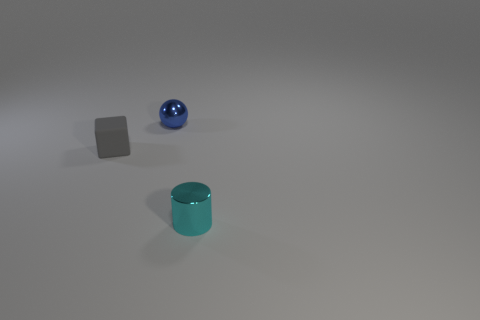Is there any other thing that has the same material as the small gray object?
Offer a terse response. No. What number of other small cubes are made of the same material as the tiny gray block?
Provide a short and direct response. 0. Is the gray object the same size as the metal cylinder?
Offer a very short reply. Yes. The thing that is in front of the small thing that is on the left side of the metal thing that is behind the cyan metallic cylinder is what shape?
Your response must be concise. Cylinder. There is a thing that is both right of the block and in front of the small sphere; what size is it?
Keep it short and to the point. Small. There is a tiny metallic thing in front of the metallic object on the left side of the cylinder; what number of tiny blocks are behind it?
Your answer should be very brief. 1. What number of large things are green metallic cylinders or blue shiny spheres?
Make the answer very short. 0. Are the small object that is to the right of the small blue thing and the sphere made of the same material?
Make the answer very short. Yes. What is the small object that is on the left side of the small metal thing that is on the left side of the cylinder in front of the blue metal object made of?
Offer a terse response. Rubber. What number of shiny things are purple cylinders or small blue balls?
Give a very brief answer. 1. 